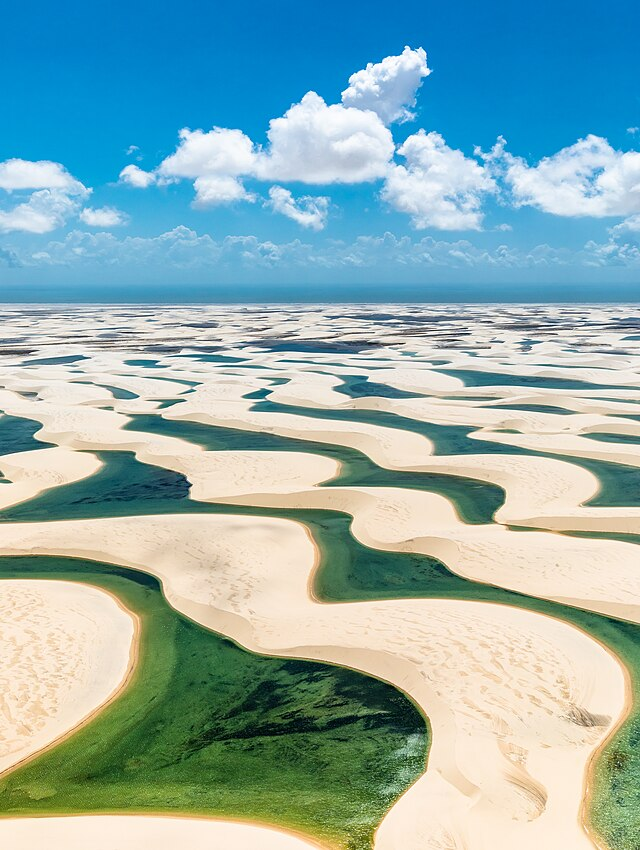How does the water remain so clear in this area, surrounded by sand dunes? The water in the lagoons of Lençóis Maranhenses remains clear due to a combination of factors. The sand in this region is largely quartz-based, which is less prone to dissolution and does not muddy the water easily. Moreover, the lagoons are temporary, formed by rainwater collected during the rainy season, and they rest on a layer of impermeable rock that prevents the water from seeping away. Together, these conditions maintain the pristine quality and clarity of the lagoons despite the encroaching sands. 